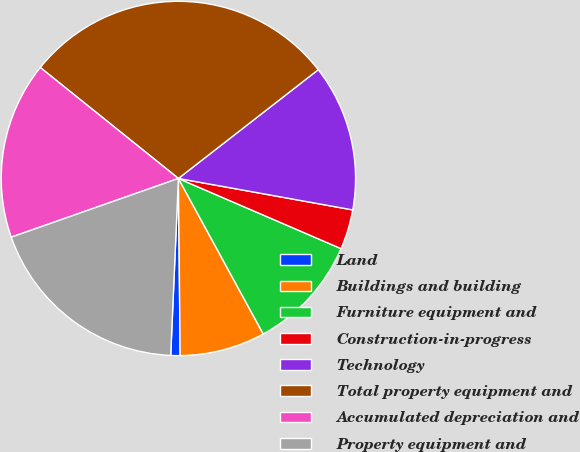Convert chart. <chart><loc_0><loc_0><loc_500><loc_500><pie_chart><fcel>Land<fcel>Buildings and building<fcel>Furniture equipment and<fcel>Construction-in-progress<fcel>Technology<fcel>Total property equipment and<fcel>Accumulated depreciation and<fcel>Property equipment and<nl><fcel>0.85%<fcel>7.79%<fcel>10.57%<fcel>3.64%<fcel>13.36%<fcel>28.71%<fcel>16.15%<fcel>18.93%<nl></chart> 